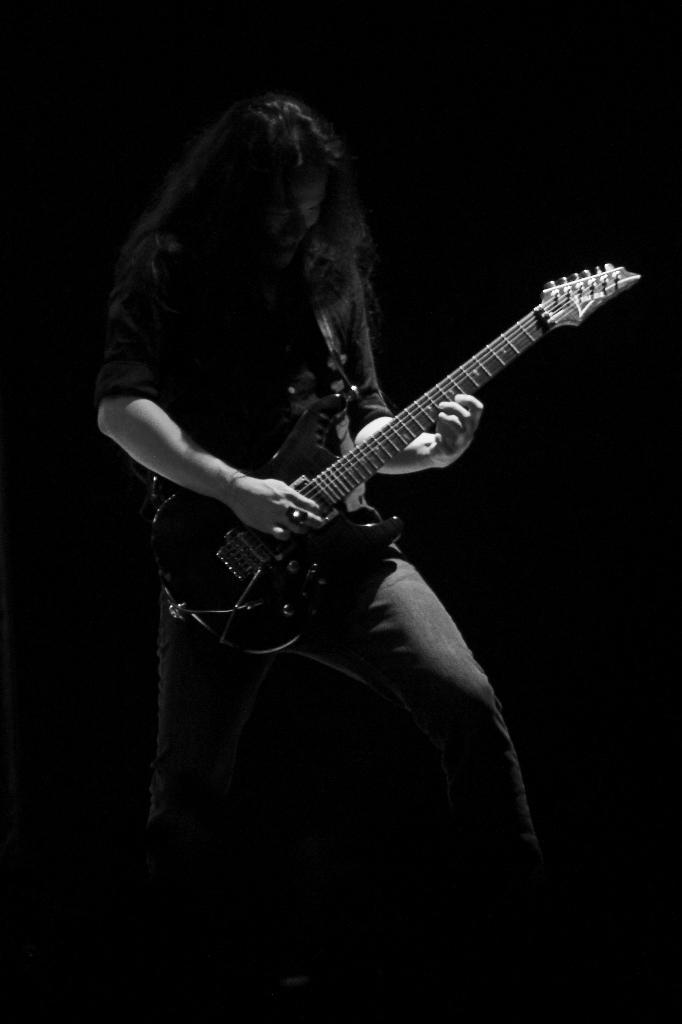What is the main subject of the image? The main subject of the image is a man. What is the man doing in the image? The man is standing and playing a guitar. What is the man wearing in the image? The man is wearing a black shirt and a pant. How many chickens are there in the image? There are no chickens present in the image. What type of tail does the man have in the image? The man does not have a tail in the image. 